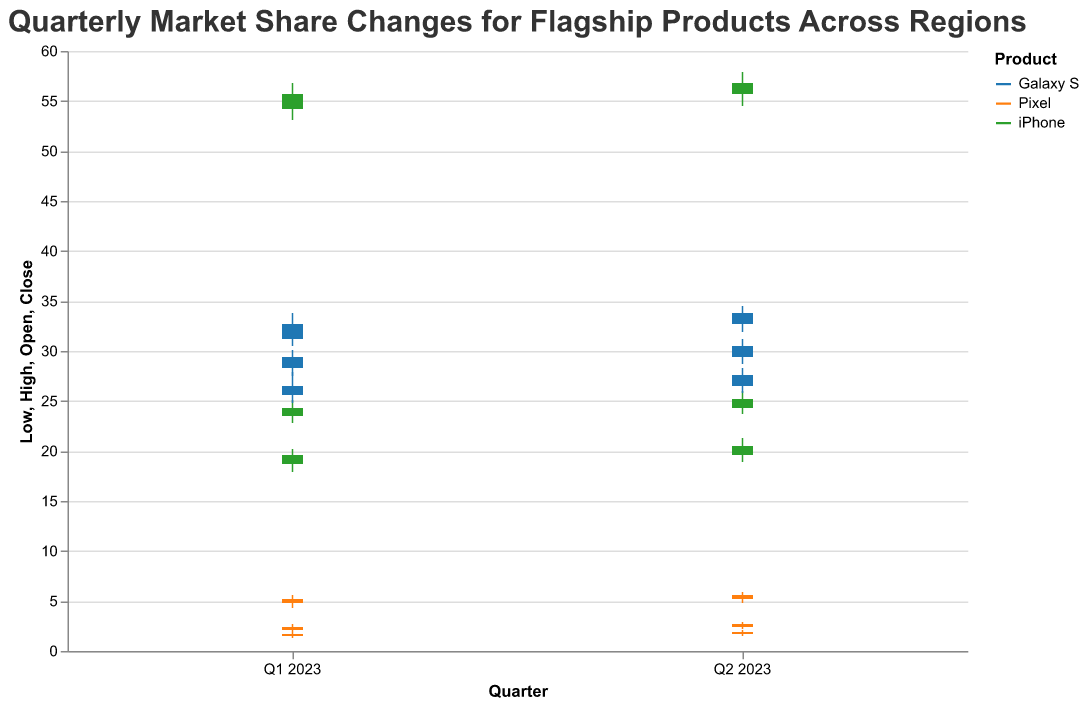What is the title of the figure? The title is displayed at the top of the figure and reads "Quarterly Market Share Changes for Flagship Products Across Regions".
Answer: Quarterly Market Share Changes for Flagship Products Across Regions Which product had the highest market share in North America in Q1 2023? The highest market share in North America in Q1 2023 can be identified by the tallest bar in the "North America" column. iPhone had the highest market share with a close value of 55.7.
Answer: iPhone What is the difference in market share for the Galaxy S in Europe between Q1 and Q2 of 2023? The close value for Galaxy S in Europe in Q1 is 32.7, and in Q2 it is 33.8. The difference is calculated by subtracting the Q1 value from the Q2 value (33.8 - 32.7).
Answer: 1.1 Which region shows the greatest variation in market share for the Pixel in Q2 2023? The variation can be identified by looking at the difference between the high and low values for each region in Q2 2023. For the Pixel in Q2, the variations are: North America (5.9 - 4.8 = 1.1), Europe (2.9 - 2.2 = 0.7), Asia Pacific (2.1 - 1.5 = 0.6). The greatest variation is in North America.
Answer: North America Which product showed consistent growth across all regions from Q1 to Q2 2023? By comparing the close values from Q1 to Q2 for each product across all regions: 
iPhone: North America (55.7 to 56.8), Europe (24.3 to 25.2), Asia Pacific (19.6 to 20.5)
Galaxy S: North America (29.4 to 30.5), Europe (32.7 to 33.8), Asia Pacific (26.5 to 27.6)
Pixel: North America (5.2 to 5.6), Europe (2.4 to 2.7), Asia Pacific (1.7 to 1.9)
All products show growth, but the iPhone is particularly consistent.
Answer: iPhone What is the average closing market share for Pixel across all regions in Q1 2023? Pixel's close values in Q1 2023 are: North America (5.2), Europe (2.4), Asia Pacific (1.7). Sum these values (5.2 + 2.4 + 1.7 = 9.3) and then divide by the number of regions (3).
Answer: 3.1 How much did iPhone's market share increase in Europe from Q1 to Q2 2023? The close value for iPhone in Europe in Q1 is 24.3, and in Q2 it is 25.2. The increase can be calculated as (25.2 - 24.3).
Answer: 0.9 Which product has the smallest market share in the Asia Pacific region in Q2 2023? The smallest market share can be identified by the smallest close value in the "Asia Pacific" column in Q2 2023. Pixel has the smallest market share with a close value of 1.9.
Answer: Pixel 